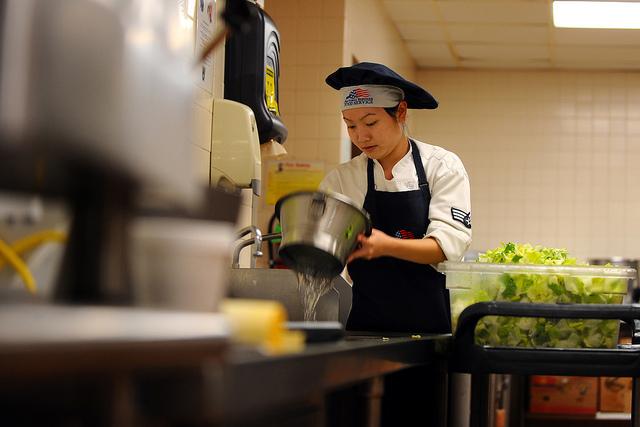What color is the apron?
Short answer required. Black. What is in the clear container?
Write a very short answer. Lettuce. Is this person baking a cake?
Keep it brief. No. 